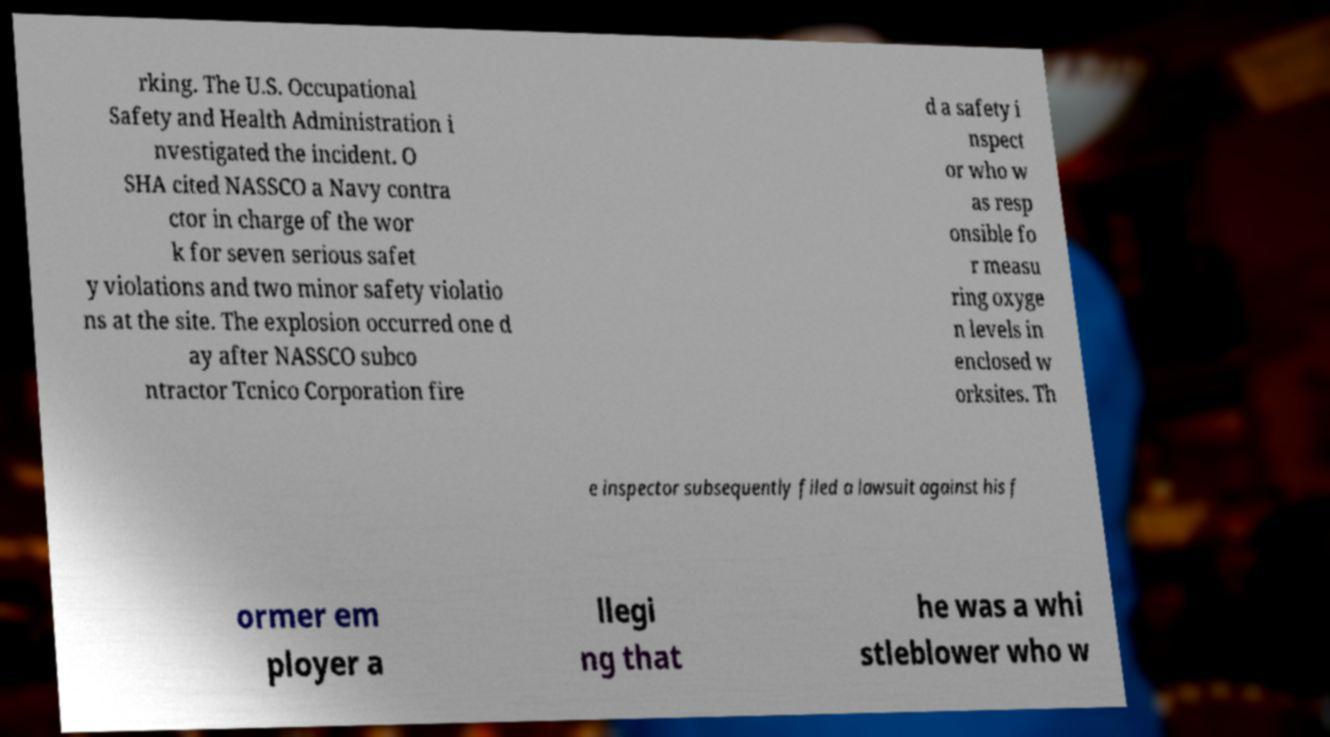Could you assist in decoding the text presented in this image and type it out clearly? rking. The U.S. Occupational Safety and Health Administration i nvestigated the incident. O SHA cited NASSCO a Navy contra ctor in charge of the wor k for seven serious safet y violations and two minor safety violatio ns at the site. The explosion occurred one d ay after NASSCO subco ntractor Tcnico Corporation fire d a safety i nspect or who w as resp onsible fo r measu ring oxyge n levels in enclosed w orksites. Th e inspector subsequently filed a lawsuit against his f ormer em ployer a llegi ng that he was a whi stleblower who w 